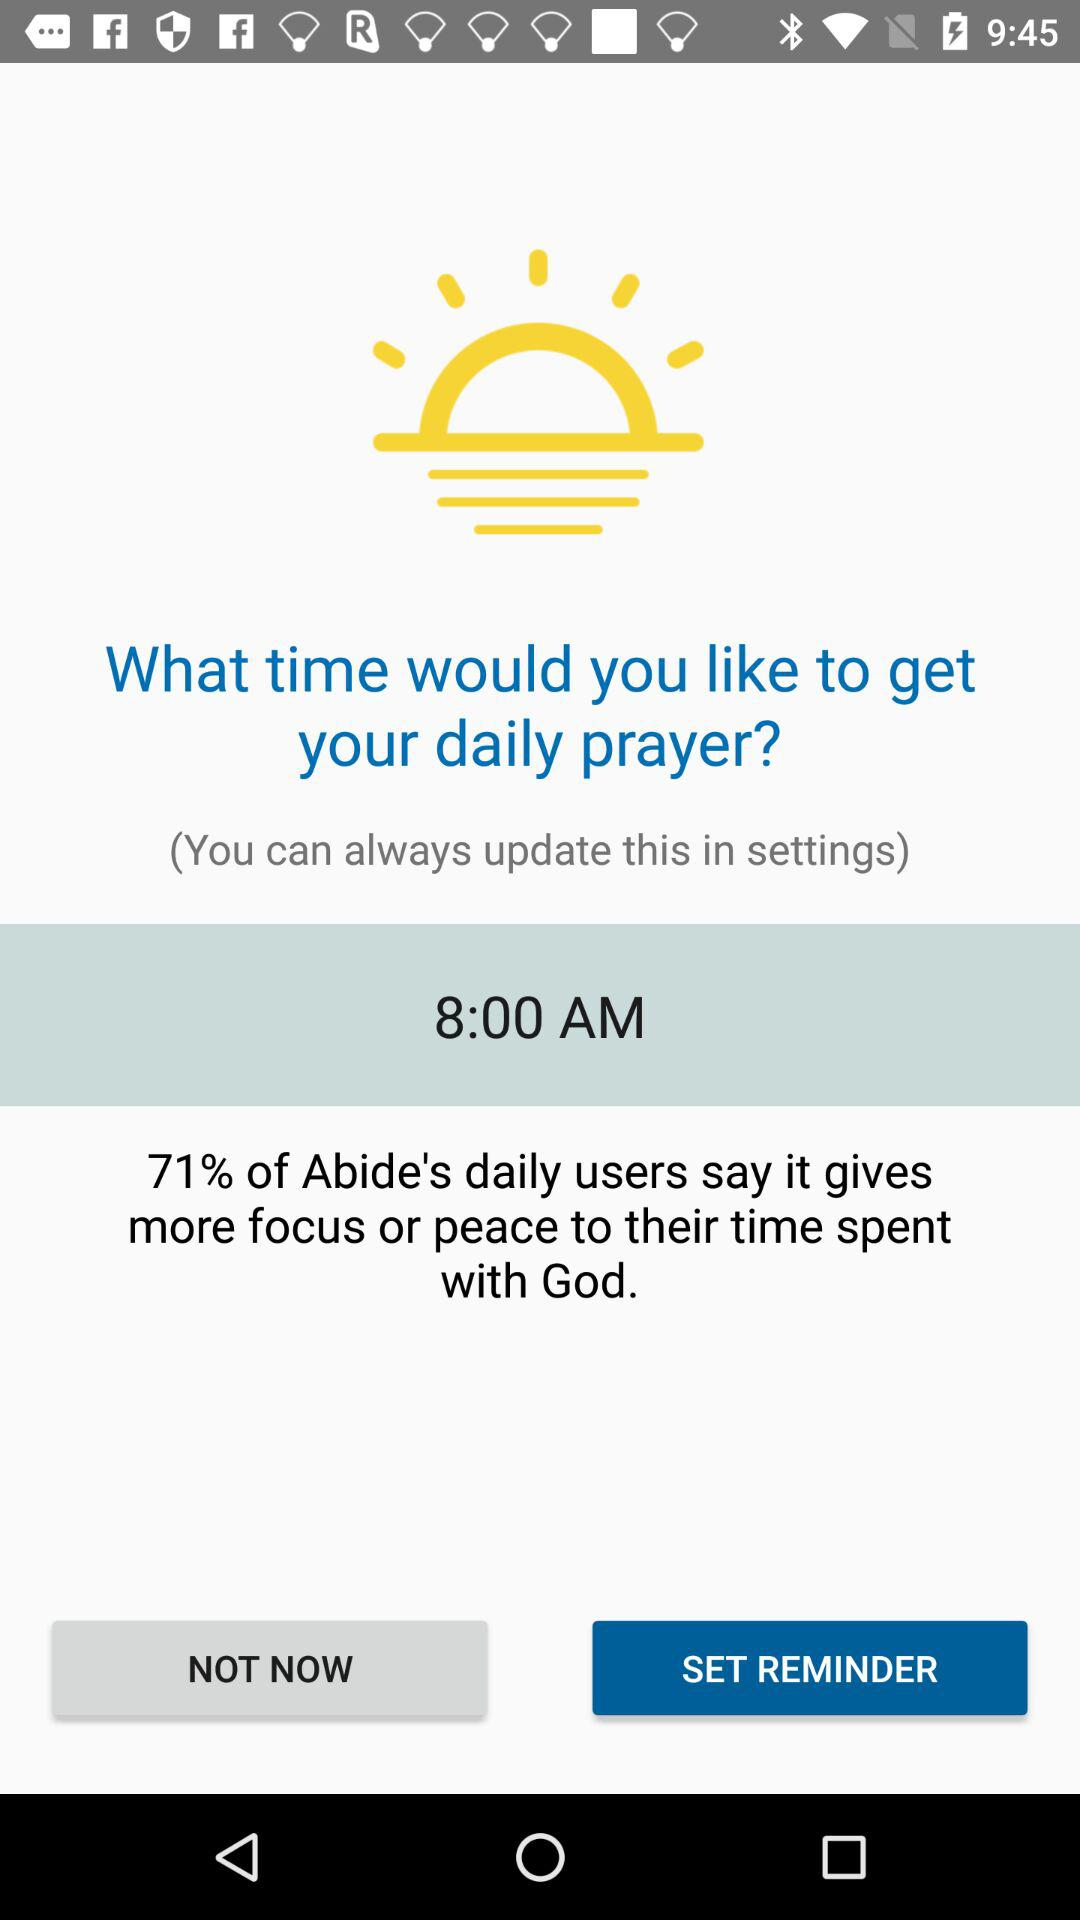What time is shown? The shown time is 8:00 a.m. 